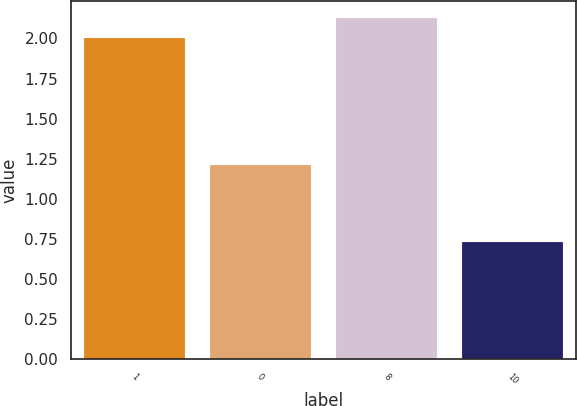<chart> <loc_0><loc_0><loc_500><loc_500><bar_chart><fcel>1<fcel>0<fcel>8<fcel>10<nl><fcel>2<fcel>1.21<fcel>2.13<fcel>0.73<nl></chart> 